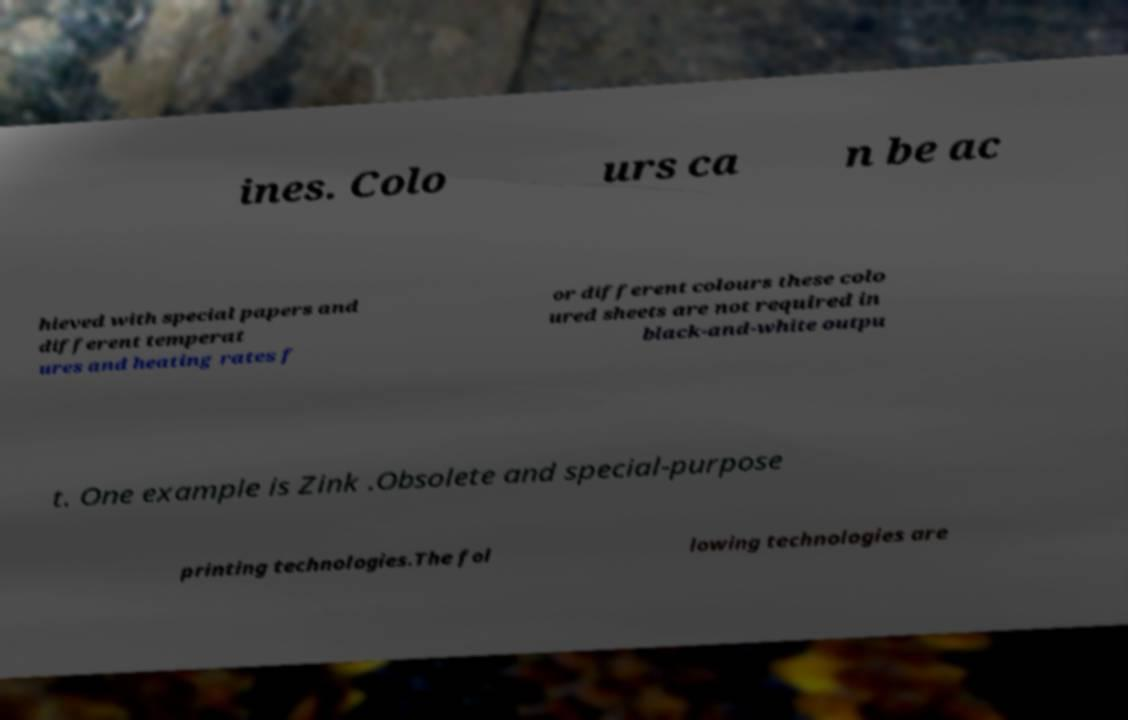Please read and relay the text visible in this image. What does it say? ines. Colo urs ca n be ac hieved with special papers and different temperat ures and heating rates f or different colours these colo ured sheets are not required in black-and-white outpu t. One example is Zink .Obsolete and special-purpose printing technologies.The fol lowing technologies are 